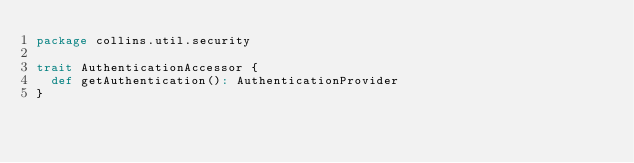Convert code to text. <code><loc_0><loc_0><loc_500><loc_500><_Scala_>package collins.util.security

trait AuthenticationAccessor {
  def getAuthentication(): AuthenticationProvider
}
</code> 